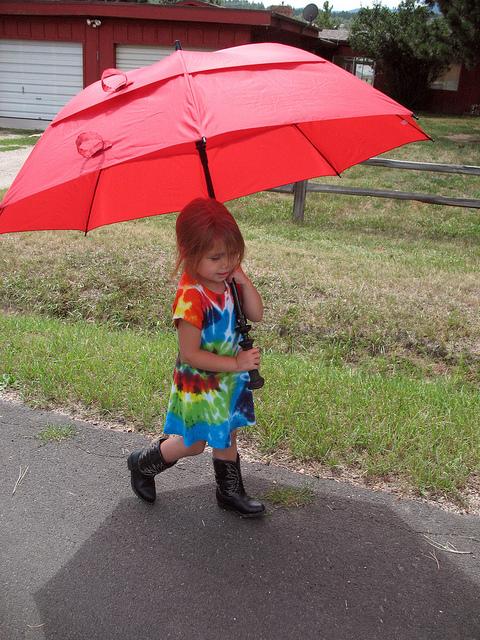What is the little girl holding?
Give a very brief answer. Umbrella. Are the people in the middle young or old?
Write a very short answer. Young. How would you describe the pattern of the little girls dress?
Write a very short answer. Tye dye. Where is the street?
Write a very short answer. Ground. Does the umbrella cast a shadow?
Quick response, please. Yes. 